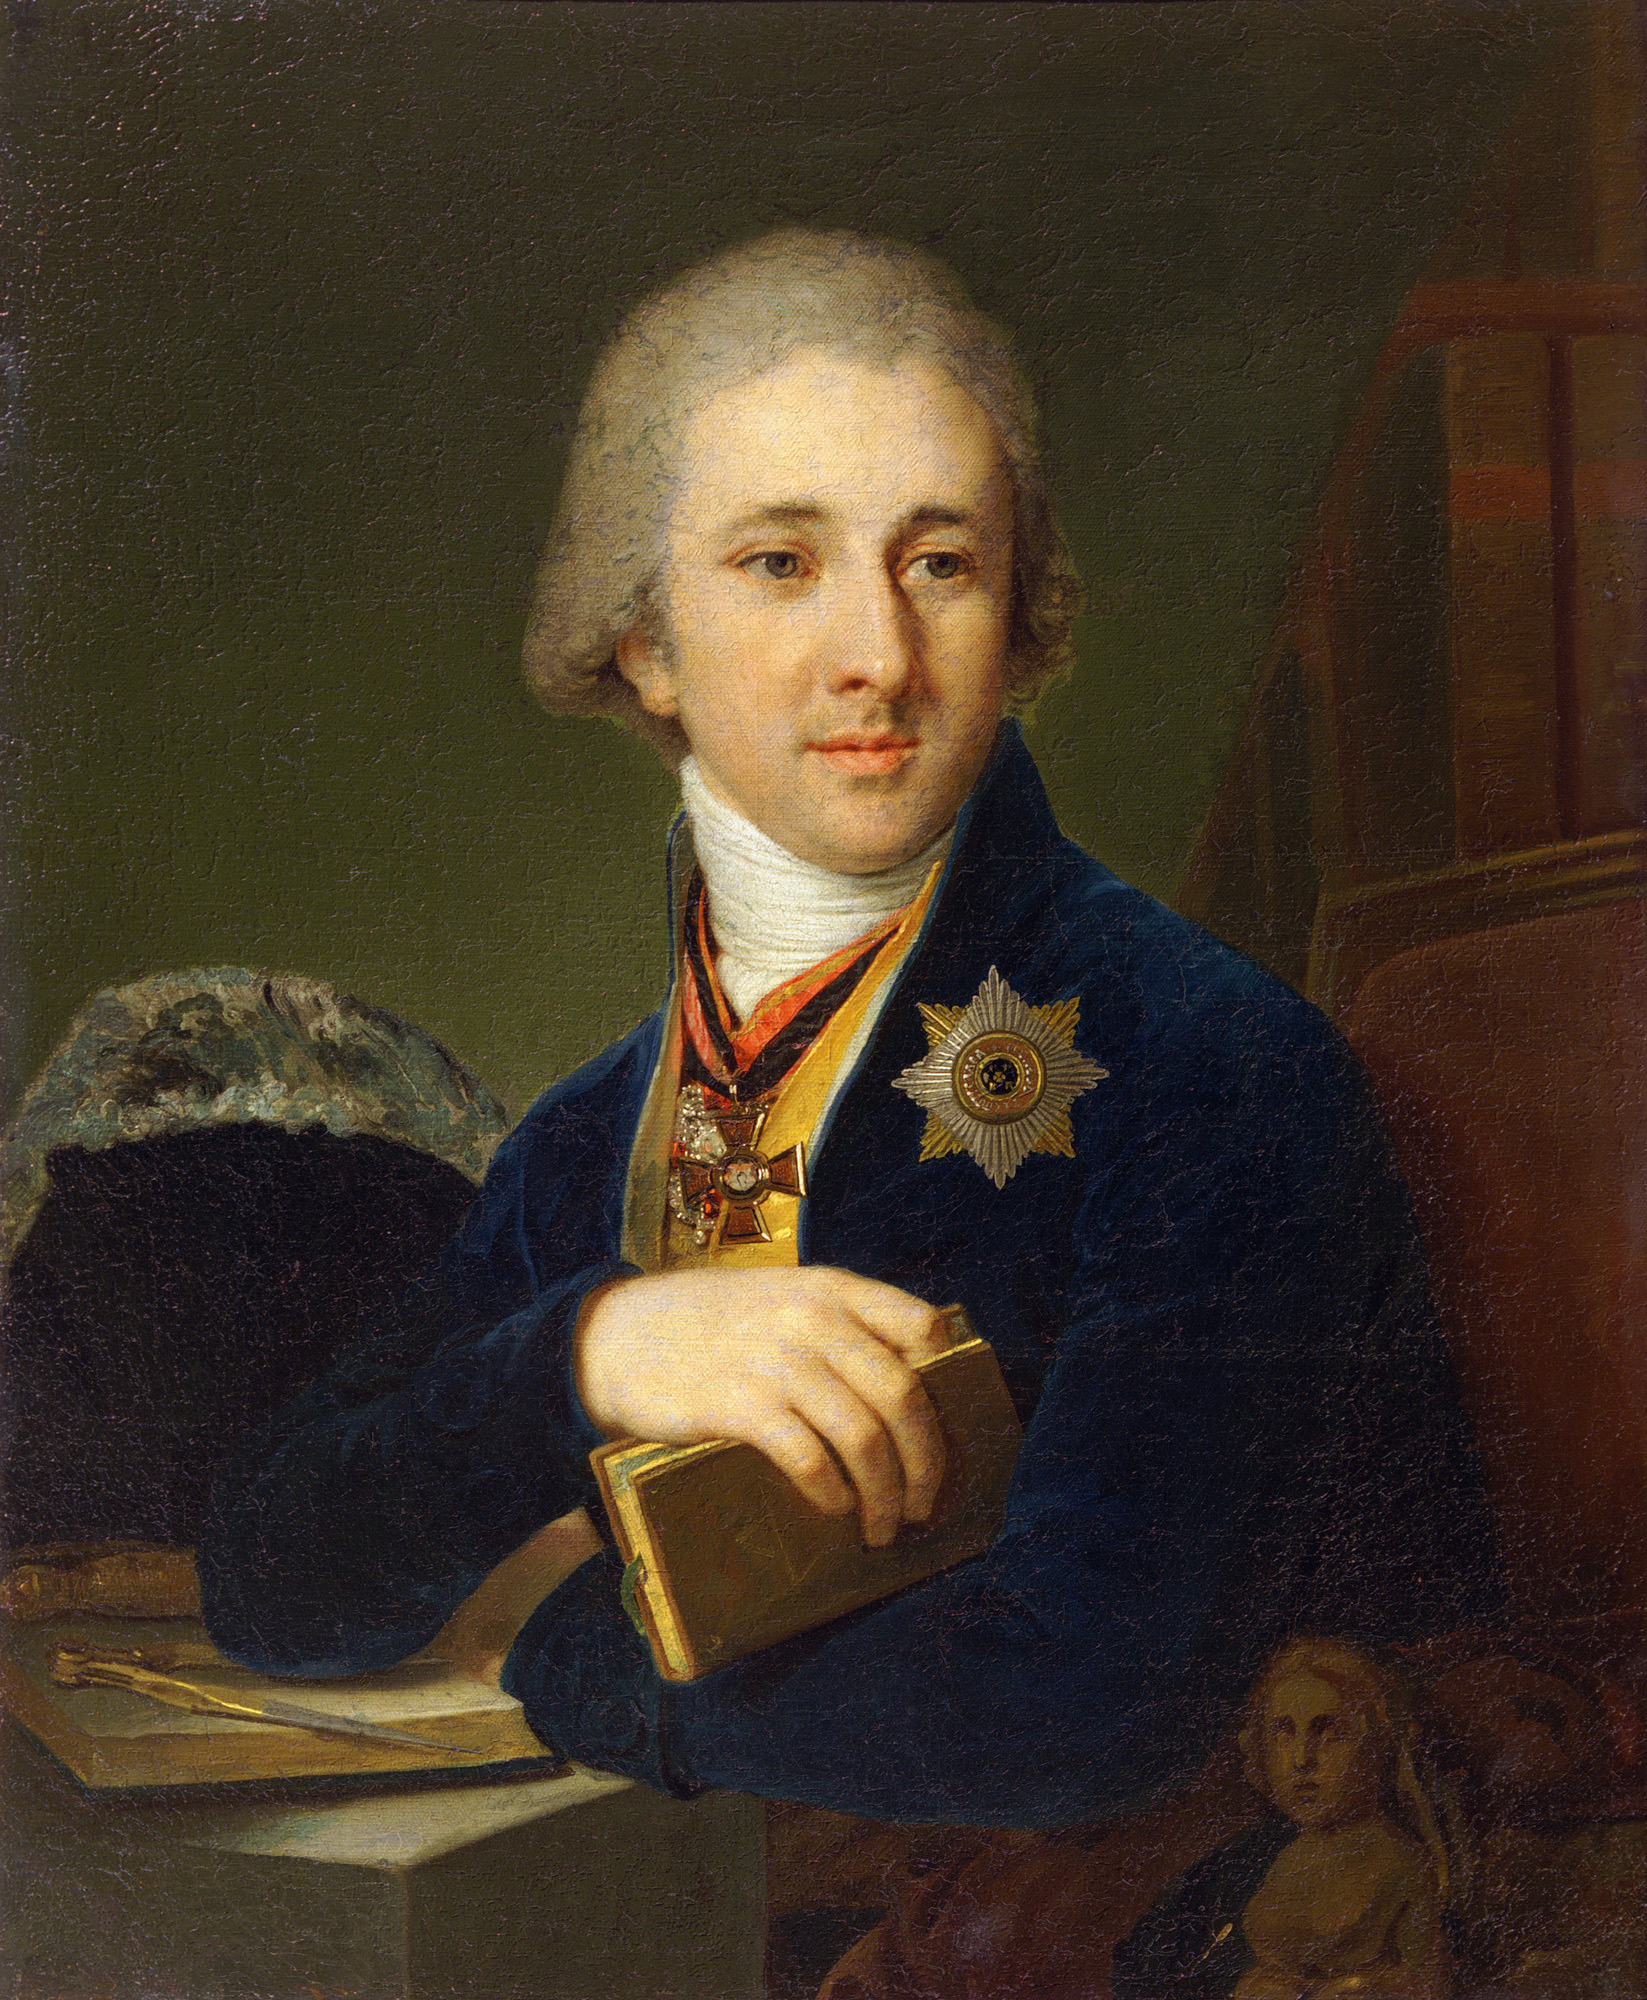Can you tell more about the significance of the medal worn by the man? The medal on the man's chest appears to be a prominent decoration, likely awarded for significant achievements or status. Such medals were commonly bestowed for contributions to scholarship, the arts, or service to a monarch or country during the 18th century. The exact type of medal, including its specific inscriptions or emblems, would provide more clues about his achievements or the honor bestowed. What could the book in his hand signify about his persona? The book held by the man, combined with his thoughtful expression and refined dress, typically symbolizes his intellectual engagement. In 18th-century portraiture, books are often used to suggest the subject's literacy, education, or involvement in scholarly or philosophical activities. It might indicate his role as a writer, thinker, or an influential figure in academia or the arts. 